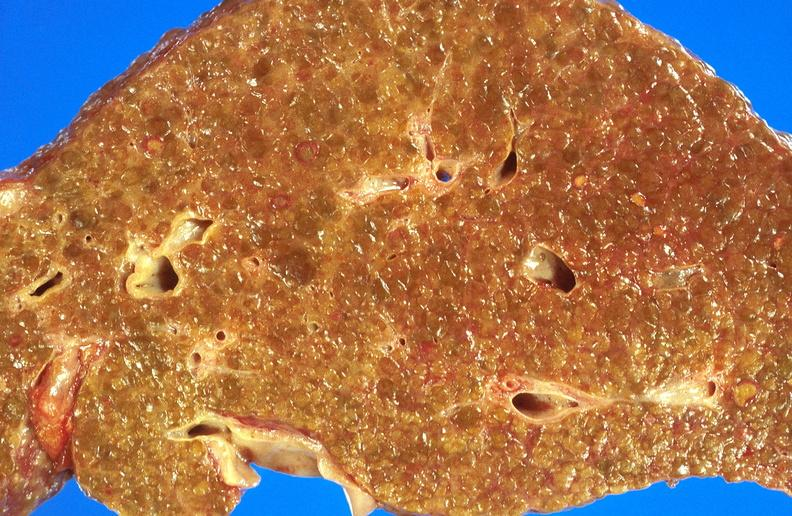does this image show alcoholic cirrhosis?
Answer the question using a single word or phrase. Yes 